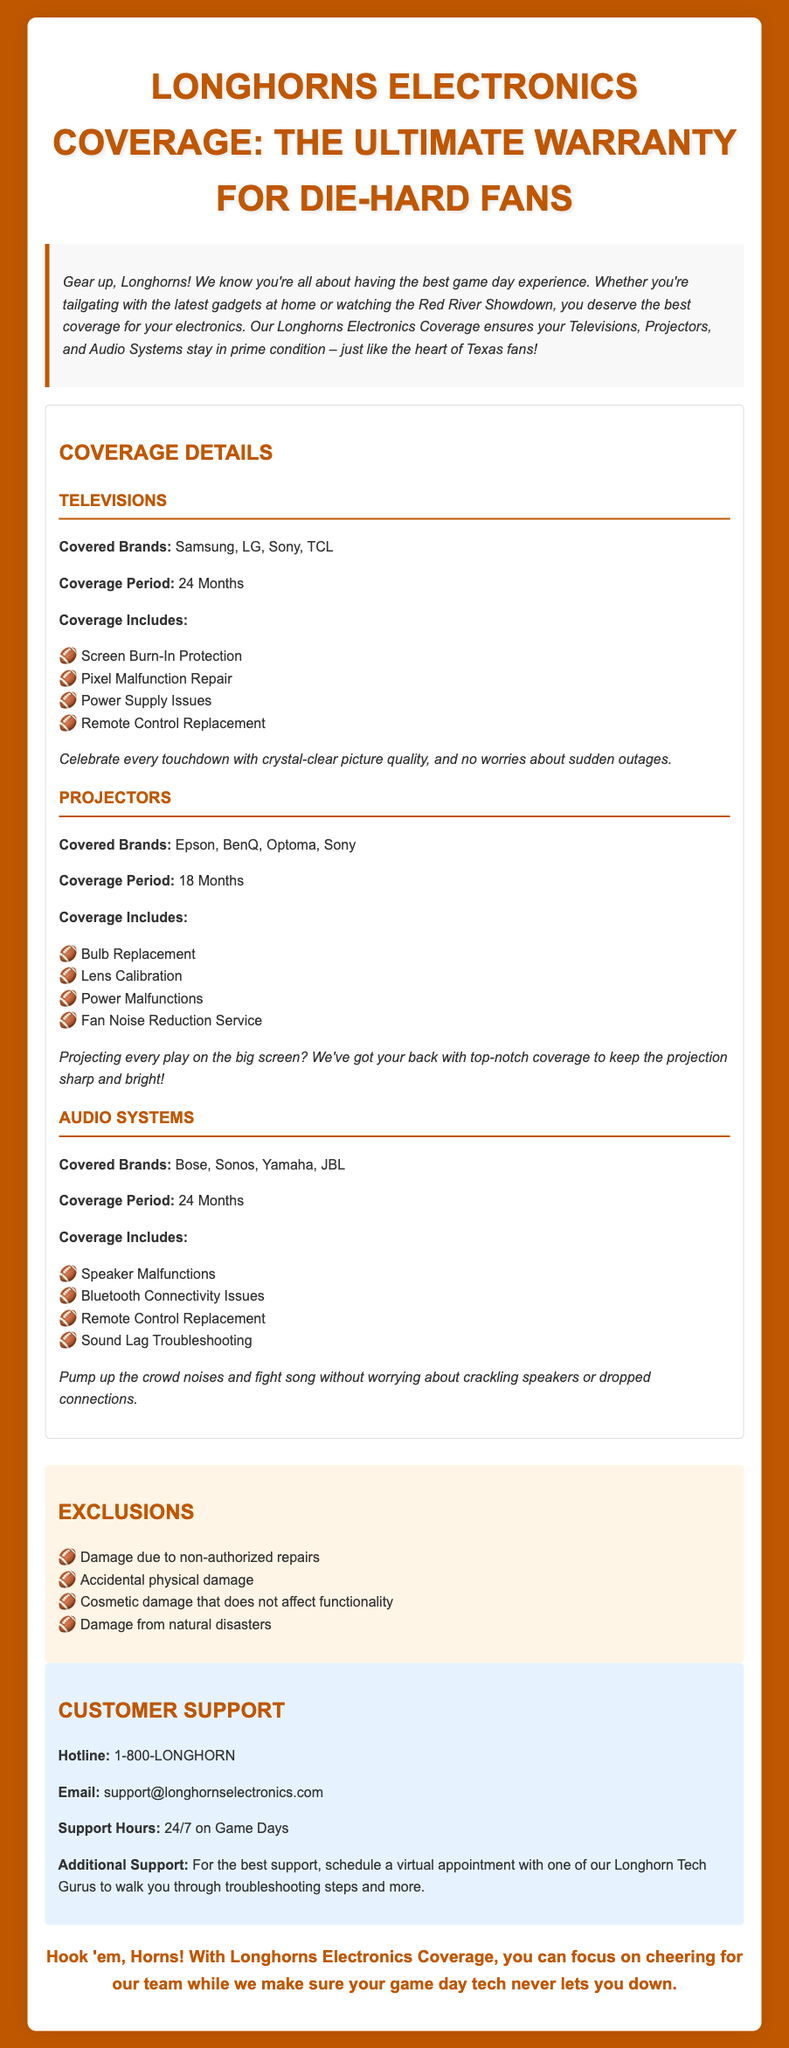What brands are covered for televisions? The section under "Televisions" lists the brands Samsung, LG, Sony, and TCL as covered.
Answer: Samsung, LG, Sony, TCL What is the coverage period for projectors? The coverage period for projectors is stated as 18 Months in the document.
Answer: 18 Months What type of coverage is included for audio systems? The section under "Audio Systems" lists Speaker Malfunctions, Bluetooth Connectivity Issues, Remote Control Replacement, and Sound Lag Troubleshooting as covered types.
Answer: Speaker Malfunctions, Bluetooth Connectivity Issues, Remote Control Replacement, Sound Lag Troubleshooting Is accidental physical damage covered? The "Exclusions" section clearly states that accidental physical damage is not covered under the warranty.
Answer: No What is the customer support hotline number? The document provides the customer support hotline number as 1-800-LONGHORN.
Answer: 1-800-LONGHORN How long is the coverage for televisions? The warranty states that the coverage for televisions is 24 Months.
Answer: 24 Months What kind of equipment does this warranty cover? The warranty covers Televisions, Projectors, and Audio Systems specifically.
Answer: Televisions, Projectors, Audio Systems What should you do for additional support? It mentions scheduling a virtual appointment with one of the Longhorn Tech Gurus for the best support.
Answer: Schedule a virtual appointment How is the introduction styled in the document? The introduction is styled with italic font and a light background, indicating it contains important initial information.
Answer: Italic font, light background 